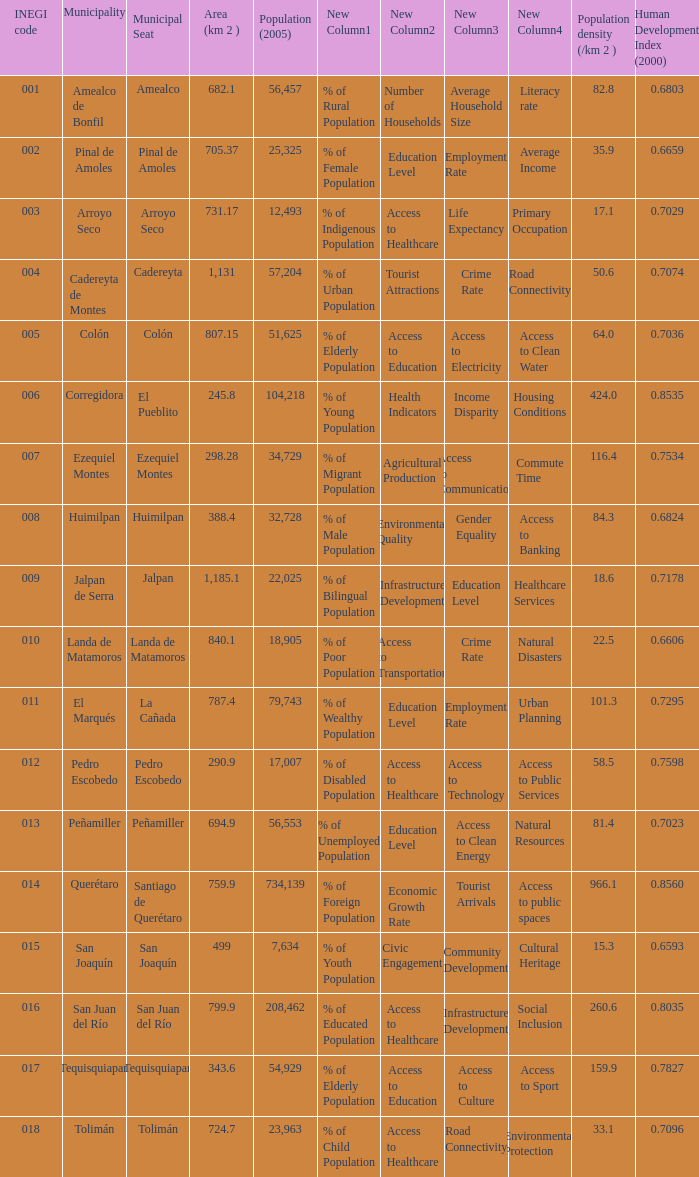WHat is the amount of Human Development Index (2000) that has a Population (2005) of 54,929, and an Area (km 2 ) larger than 343.6? 0.0. 